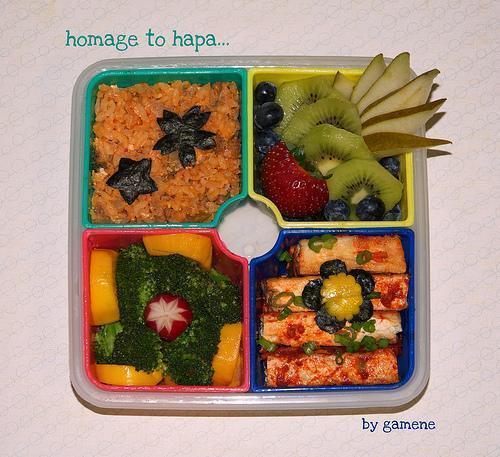How many food sections are in the picture?
Give a very brief answer. 4. How many kiwi on the right side of the tray?
Give a very brief answer. 4. 